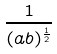<formula> <loc_0><loc_0><loc_500><loc_500>\frac { 1 } { ( a b ) ^ { \frac { 1 } { 2 } } }</formula> 